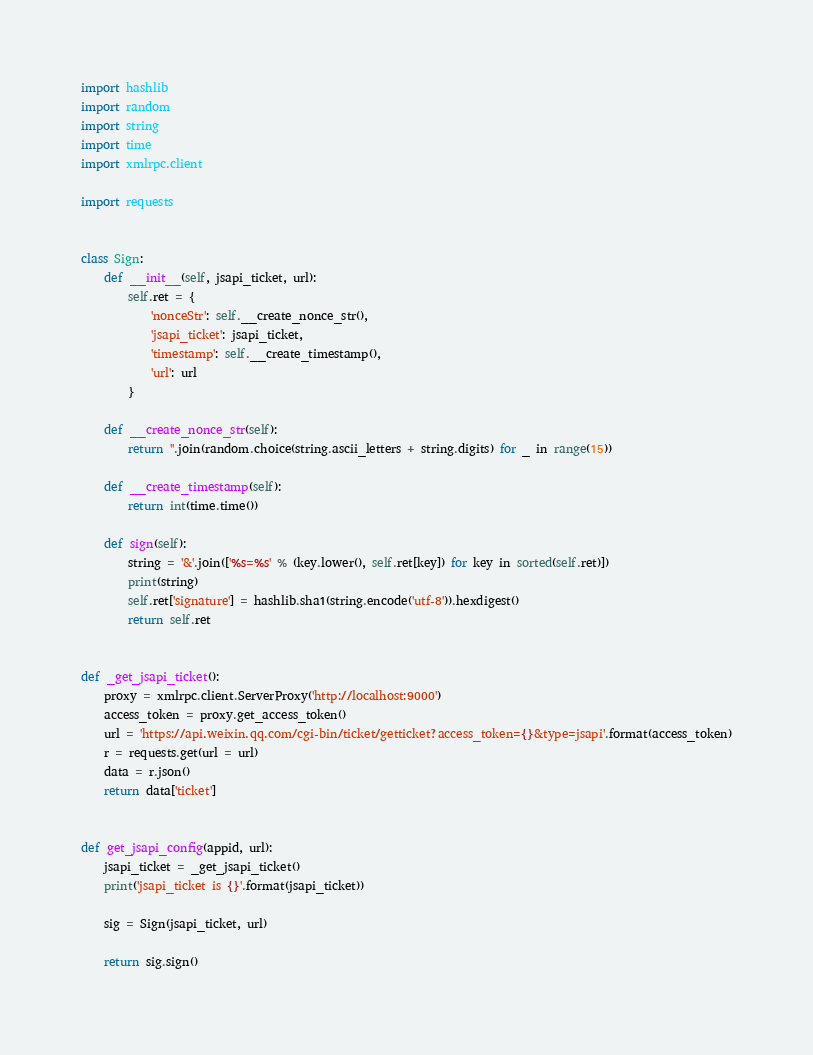Convert code to text. <code><loc_0><loc_0><loc_500><loc_500><_Python_>
import hashlib
import random
import string
import time
import xmlrpc.client

import requests


class Sign:
    def __init__(self, jsapi_ticket, url):
        self.ret = {
            'nonceStr': self.__create_nonce_str(),
            'jsapi_ticket': jsapi_ticket,
            'timestamp': self.__create_timestamp(),
            'url': url
        }

    def __create_nonce_str(self):
        return ''.join(random.choice(string.ascii_letters + string.digits) for _ in range(15))

    def __create_timestamp(self):
        return int(time.time())

    def sign(self):
        string = '&'.join(['%s=%s' % (key.lower(), self.ret[key]) for key in sorted(self.ret)])
        print(string)
        self.ret['signature'] = hashlib.sha1(string.encode('utf-8')).hexdigest()
        return self.ret


def _get_jsapi_ticket():
    proxy = xmlrpc.client.ServerProxy('http://localhost:9000')
    access_token = proxy.get_access_token()
    url = 'https://api.weixin.qq.com/cgi-bin/ticket/getticket?access_token={}&type=jsapi'.format(access_token)
    r = requests.get(url = url)
    data = r.json()
    return data['ticket']


def get_jsapi_config(appid, url):
    jsapi_ticket = _get_jsapi_ticket()
    print('jsapi_ticket is {}'.format(jsapi_ticket))

    sig = Sign(jsapi_ticket, url)

    return sig.sign() 
</code> 